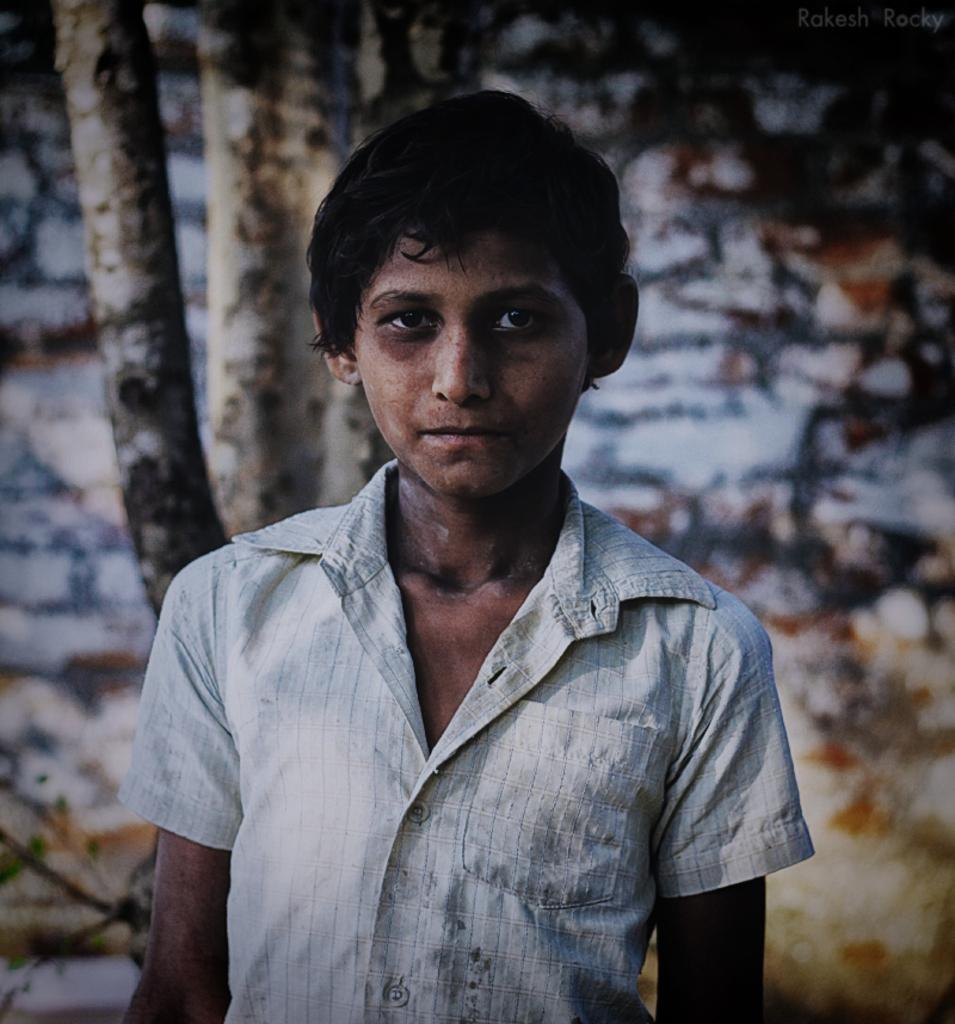What is the main subject of the image? There is a boy standing in the image. What can be seen in the background of the image? There are tree trunks in the background of the image. How would you describe the background of the image? The background of the image is blurry. Where is the text located in the image? The text is in the top right corner of the image. How many cats are sleeping on the bed in the image? There is no bed or cats present in the image. What type of ants can be seen crawling on the tree trunks in the image? There are no ants visible in the image; only tree trunks are present in the background. 